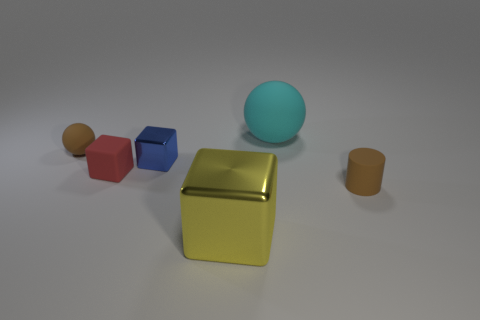There is a brown object that is right of the tiny brown sphere; is it the same size as the brown matte object that is left of the large rubber ball?
Your answer should be compact. Yes. How many other things are there of the same size as the yellow cube?
Offer a very short reply. 1. Are there any large matte objects to the left of the small brown rubber thing that is in front of the tiny brown thing to the left of the big cube?
Your answer should be very brief. Yes. Are there any other things that are the same color as the rubber cylinder?
Keep it short and to the point. Yes. What is the size of the brown thing in front of the tiny brown rubber sphere?
Offer a very short reply. Small. There is a brown object that is in front of the brown object behind the small brown object in front of the brown sphere; what is its size?
Offer a very short reply. Small. The sphere that is to the right of the matte ball left of the big cyan sphere is what color?
Offer a terse response. Cyan. There is a red object that is the same shape as the yellow thing; what material is it?
Ensure brevity in your answer.  Rubber. There is a yellow metal thing; are there any red cubes right of it?
Give a very brief answer. No. How many rubber objects are there?
Provide a short and direct response. 4. 